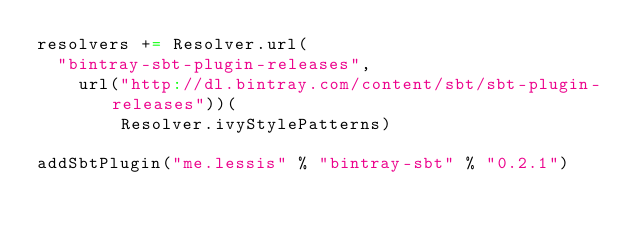<code> <loc_0><loc_0><loc_500><loc_500><_Scala_>resolvers += Resolver.url(
  "bintray-sbt-plugin-releases",
    url("http://dl.bintray.com/content/sbt/sbt-plugin-releases"))(
        Resolver.ivyStylePatterns)

addSbtPlugin("me.lessis" % "bintray-sbt" % "0.2.1")
</code> 